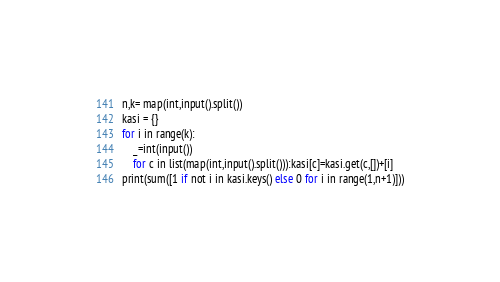Convert code to text. <code><loc_0><loc_0><loc_500><loc_500><_Python_>n,k= map(int,input().split())
kasi = {}
for i in range(k):
    _=int(input())
    for c in list(map(int,input().split())):kasi[c]=kasi.get(c,[])+[i]
print(sum([1 if not i in kasi.keys() else 0 for i in range(1,n+1)]))</code> 